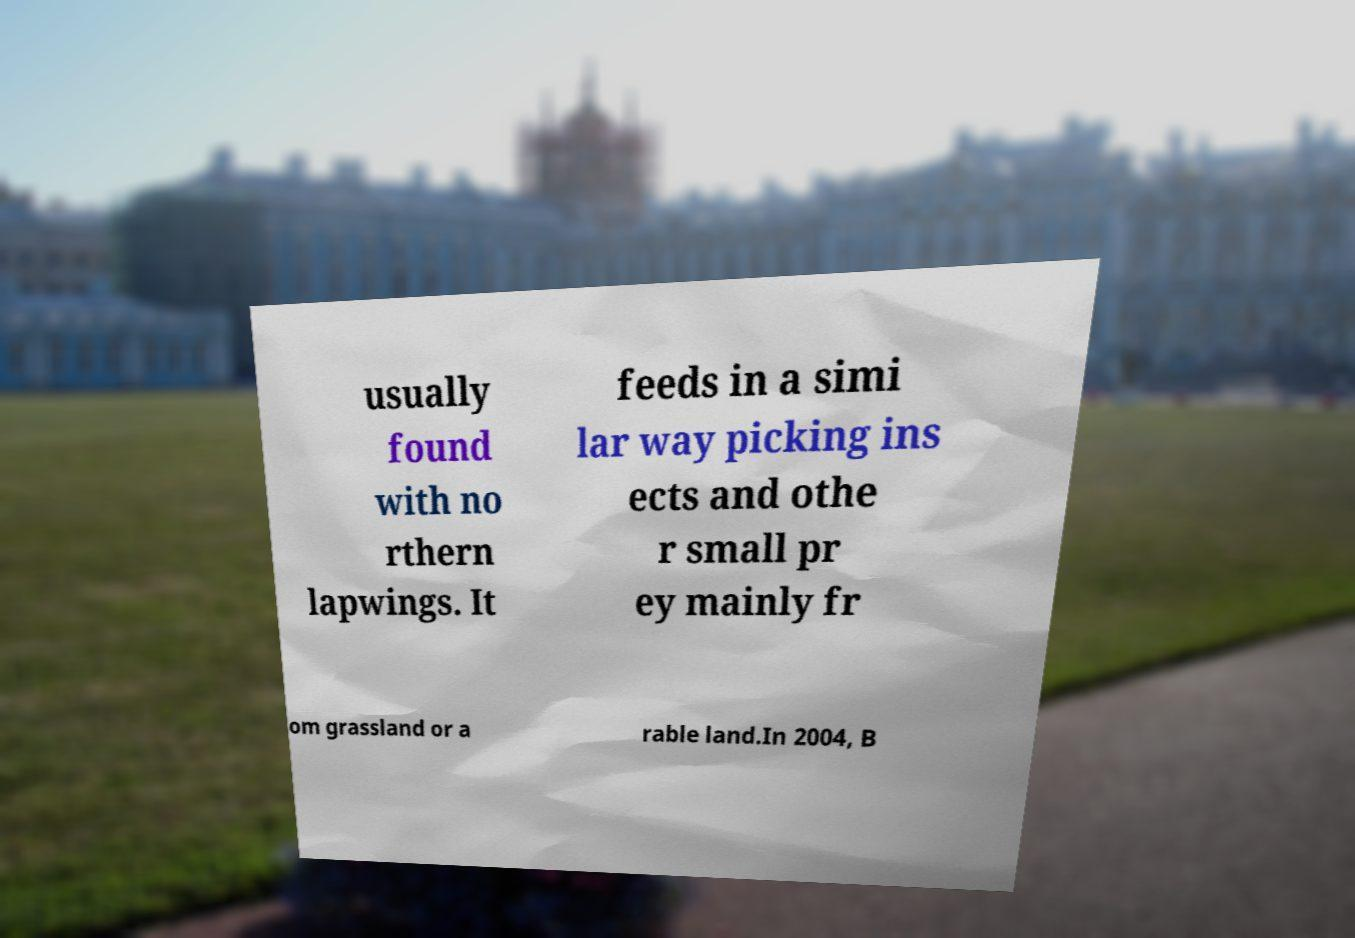I need the written content from this picture converted into text. Can you do that? usually found with no rthern lapwings. It feeds in a simi lar way picking ins ects and othe r small pr ey mainly fr om grassland or a rable land.In 2004, B 